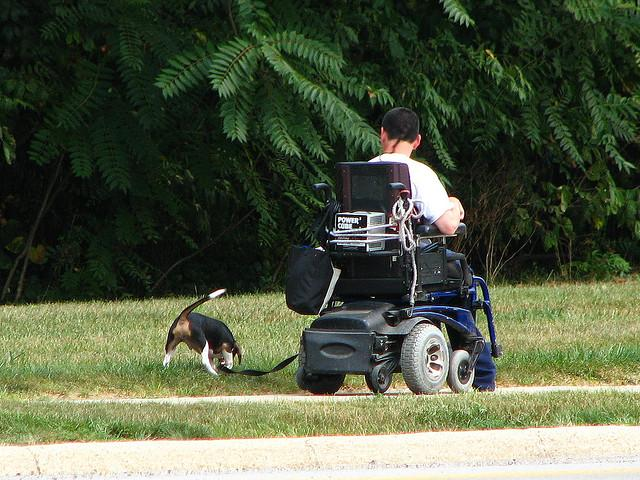What is the purpose of the power cube on the back of the wheelchair? charging 